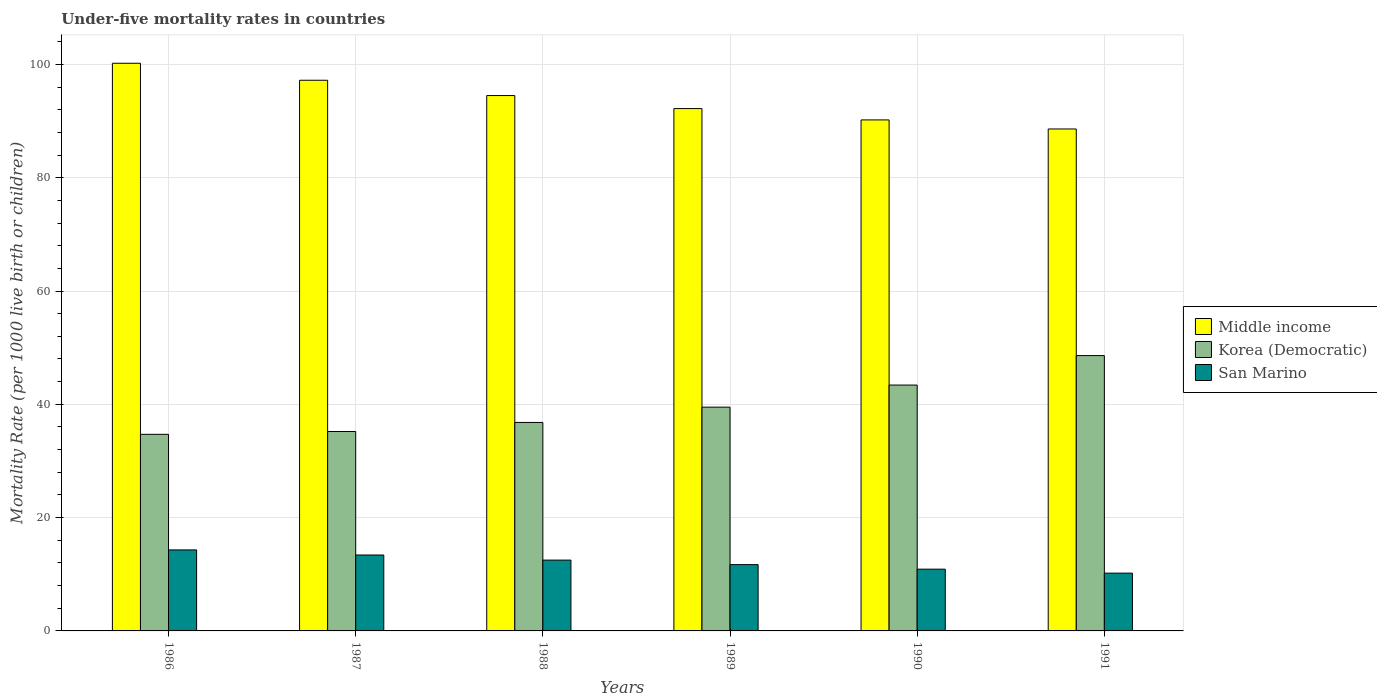How many groups of bars are there?
Provide a succinct answer. 6. What is the label of the 4th group of bars from the left?
Keep it short and to the point. 1989. What is the under-five mortality rate in Middle income in 1991?
Provide a short and direct response. 88.6. Across all years, what is the maximum under-five mortality rate in San Marino?
Offer a terse response. 14.3. Across all years, what is the minimum under-five mortality rate in Middle income?
Provide a short and direct response. 88.6. In which year was the under-five mortality rate in Korea (Democratic) maximum?
Provide a succinct answer. 1991. In which year was the under-five mortality rate in San Marino minimum?
Your response must be concise. 1991. What is the total under-five mortality rate in Middle income in the graph?
Give a very brief answer. 562.9. What is the difference between the under-five mortality rate in San Marino in 1986 and that in 1987?
Offer a terse response. 0.9. What is the difference between the under-five mortality rate in San Marino in 1987 and the under-five mortality rate in Middle income in 1989?
Keep it short and to the point. -78.8. What is the average under-five mortality rate in Korea (Democratic) per year?
Offer a very short reply. 39.7. In the year 1986, what is the difference between the under-five mortality rate in Korea (Democratic) and under-five mortality rate in San Marino?
Give a very brief answer. 20.4. In how many years, is the under-five mortality rate in Middle income greater than 96?
Offer a very short reply. 2. What is the ratio of the under-five mortality rate in Middle income in 1988 to that in 1990?
Provide a succinct answer. 1.05. Is the under-five mortality rate in Middle income in 1988 less than that in 1989?
Offer a very short reply. No. What is the difference between the highest and the second highest under-five mortality rate in San Marino?
Your response must be concise. 0.9. What is the difference between the highest and the lowest under-five mortality rate in Middle income?
Ensure brevity in your answer.  11.6. Is the sum of the under-five mortality rate in Middle income in 1989 and 1991 greater than the maximum under-five mortality rate in San Marino across all years?
Offer a terse response. Yes. What does the 3rd bar from the left in 1990 represents?
Offer a terse response. San Marino. What does the 3rd bar from the right in 1986 represents?
Provide a succinct answer. Middle income. Does the graph contain any zero values?
Your answer should be compact. No. How many legend labels are there?
Your answer should be very brief. 3. How are the legend labels stacked?
Ensure brevity in your answer.  Vertical. What is the title of the graph?
Your answer should be compact. Under-five mortality rates in countries. What is the label or title of the X-axis?
Keep it short and to the point. Years. What is the label or title of the Y-axis?
Your answer should be compact. Mortality Rate (per 1000 live birth or children). What is the Mortality Rate (per 1000 live birth or children) in Middle income in 1986?
Offer a terse response. 100.2. What is the Mortality Rate (per 1000 live birth or children) of Korea (Democratic) in 1986?
Provide a short and direct response. 34.7. What is the Mortality Rate (per 1000 live birth or children) in Middle income in 1987?
Provide a succinct answer. 97.2. What is the Mortality Rate (per 1000 live birth or children) of Korea (Democratic) in 1987?
Your answer should be very brief. 35.2. What is the Mortality Rate (per 1000 live birth or children) in Middle income in 1988?
Provide a short and direct response. 94.5. What is the Mortality Rate (per 1000 live birth or children) of Korea (Democratic) in 1988?
Provide a succinct answer. 36.8. What is the Mortality Rate (per 1000 live birth or children) of San Marino in 1988?
Give a very brief answer. 12.5. What is the Mortality Rate (per 1000 live birth or children) of Middle income in 1989?
Provide a short and direct response. 92.2. What is the Mortality Rate (per 1000 live birth or children) of Korea (Democratic) in 1989?
Keep it short and to the point. 39.5. What is the Mortality Rate (per 1000 live birth or children) in San Marino in 1989?
Ensure brevity in your answer.  11.7. What is the Mortality Rate (per 1000 live birth or children) in Middle income in 1990?
Provide a short and direct response. 90.2. What is the Mortality Rate (per 1000 live birth or children) of Korea (Democratic) in 1990?
Ensure brevity in your answer.  43.4. What is the Mortality Rate (per 1000 live birth or children) in Middle income in 1991?
Keep it short and to the point. 88.6. What is the Mortality Rate (per 1000 live birth or children) in Korea (Democratic) in 1991?
Your answer should be compact. 48.6. What is the Mortality Rate (per 1000 live birth or children) of San Marino in 1991?
Provide a short and direct response. 10.2. Across all years, what is the maximum Mortality Rate (per 1000 live birth or children) in Middle income?
Offer a terse response. 100.2. Across all years, what is the maximum Mortality Rate (per 1000 live birth or children) of Korea (Democratic)?
Your response must be concise. 48.6. Across all years, what is the maximum Mortality Rate (per 1000 live birth or children) in San Marino?
Your answer should be very brief. 14.3. Across all years, what is the minimum Mortality Rate (per 1000 live birth or children) of Middle income?
Keep it short and to the point. 88.6. Across all years, what is the minimum Mortality Rate (per 1000 live birth or children) of Korea (Democratic)?
Make the answer very short. 34.7. Across all years, what is the minimum Mortality Rate (per 1000 live birth or children) in San Marino?
Provide a succinct answer. 10.2. What is the total Mortality Rate (per 1000 live birth or children) of Middle income in the graph?
Give a very brief answer. 562.9. What is the total Mortality Rate (per 1000 live birth or children) of Korea (Democratic) in the graph?
Offer a very short reply. 238.2. What is the total Mortality Rate (per 1000 live birth or children) of San Marino in the graph?
Offer a terse response. 73. What is the difference between the Mortality Rate (per 1000 live birth or children) in Middle income in 1986 and that in 1987?
Your response must be concise. 3. What is the difference between the Mortality Rate (per 1000 live birth or children) of Korea (Democratic) in 1986 and that in 1987?
Provide a short and direct response. -0.5. What is the difference between the Mortality Rate (per 1000 live birth or children) in San Marino in 1986 and that in 1987?
Your response must be concise. 0.9. What is the difference between the Mortality Rate (per 1000 live birth or children) in Middle income in 1986 and that in 1988?
Make the answer very short. 5.7. What is the difference between the Mortality Rate (per 1000 live birth or children) of Korea (Democratic) in 1986 and that in 1988?
Provide a succinct answer. -2.1. What is the difference between the Mortality Rate (per 1000 live birth or children) of Middle income in 1986 and that in 1989?
Your answer should be compact. 8. What is the difference between the Mortality Rate (per 1000 live birth or children) in Korea (Democratic) in 1986 and that in 1989?
Provide a short and direct response. -4.8. What is the difference between the Mortality Rate (per 1000 live birth or children) of Korea (Democratic) in 1986 and that in 1990?
Give a very brief answer. -8.7. What is the difference between the Mortality Rate (per 1000 live birth or children) in San Marino in 1986 and that in 1990?
Your answer should be compact. 3.4. What is the difference between the Mortality Rate (per 1000 live birth or children) in Middle income in 1986 and that in 1991?
Your answer should be compact. 11.6. What is the difference between the Mortality Rate (per 1000 live birth or children) of Korea (Democratic) in 1986 and that in 1991?
Provide a short and direct response. -13.9. What is the difference between the Mortality Rate (per 1000 live birth or children) in Middle income in 1987 and that in 1988?
Offer a very short reply. 2.7. What is the difference between the Mortality Rate (per 1000 live birth or children) of Korea (Democratic) in 1987 and that in 1988?
Your response must be concise. -1.6. What is the difference between the Mortality Rate (per 1000 live birth or children) of Korea (Democratic) in 1987 and that in 1989?
Ensure brevity in your answer.  -4.3. What is the difference between the Mortality Rate (per 1000 live birth or children) in San Marino in 1987 and that in 1989?
Your answer should be very brief. 1.7. What is the difference between the Mortality Rate (per 1000 live birth or children) of Middle income in 1987 and that in 1990?
Your answer should be very brief. 7. What is the difference between the Mortality Rate (per 1000 live birth or children) in Korea (Democratic) in 1987 and that in 1990?
Ensure brevity in your answer.  -8.2. What is the difference between the Mortality Rate (per 1000 live birth or children) of Korea (Democratic) in 1987 and that in 1991?
Offer a very short reply. -13.4. What is the difference between the Mortality Rate (per 1000 live birth or children) of Middle income in 1988 and that in 1989?
Give a very brief answer. 2.3. What is the difference between the Mortality Rate (per 1000 live birth or children) in Middle income in 1988 and that in 1990?
Your answer should be very brief. 4.3. What is the difference between the Mortality Rate (per 1000 live birth or children) in Korea (Democratic) in 1988 and that in 1990?
Ensure brevity in your answer.  -6.6. What is the difference between the Mortality Rate (per 1000 live birth or children) of San Marino in 1988 and that in 1990?
Ensure brevity in your answer.  1.6. What is the difference between the Mortality Rate (per 1000 live birth or children) of Korea (Democratic) in 1988 and that in 1991?
Offer a terse response. -11.8. What is the difference between the Mortality Rate (per 1000 live birth or children) of Middle income in 1989 and that in 1990?
Your response must be concise. 2. What is the difference between the Mortality Rate (per 1000 live birth or children) in Korea (Democratic) in 1989 and that in 1990?
Ensure brevity in your answer.  -3.9. What is the difference between the Mortality Rate (per 1000 live birth or children) of Middle income in 1989 and that in 1991?
Make the answer very short. 3.6. What is the difference between the Mortality Rate (per 1000 live birth or children) of Korea (Democratic) in 1989 and that in 1991?
Your response must be concise. -9.1. What is the difference between the Mortality Rate (per 1000 live birth or children) in San Marino in 1989 and that in 1991?
Provide a short and direct response. 1.5. What is the difference between the Mortality Rate (per 1000 live birth or children) of Korea (Democratic) in 1990 and that in 1991?
Your answer should be very brief. -5.2. What is the difference between the Mortality Rate (per 1000 live birth or children) in Middle income in 1986 and the Mortality Rate (per 1000 live birth or children) in Korea (Democratic) in 1987?
Provide a succinct answer. 65. What is the difference between the Mortality Rate (per 1000 live birth or children) in Middle income in 1986 and the Mortality Rate (per 1000 live birth or children) in San Marino in 1987?
Give a very brief answer. 86.8. What is the difference between the Mortality Rate (per 1000 live birth or children) in Korea (Democratic) in 1986 and the Mortality Rate (per 1000 live birth or children) in San Marino in 1987?
Provide a succinct answer. 21.3. What is the difference between the Mortality Rate (per 1000 live birth or children) in Middle income in 1986 and the Mortality Rate (per 1000 live birth or children) in Korea (Democratic) in 1988?
Keep it short and to the point. 63.4. What is the difference between the Mortality Rate (per 1000 live birth or children) of Middle income in 1986 and the Mortality Rate (per 1000 live birth or children) of San Marino in 1988?
Your response must be concise. 87.7. What is the difference between the Mortality Rate (per 1000 live birth or children) in Middle income in 1986 and the Mortality Rate (per 1000 live birth or children) in Korea (Democratic) in 1989?
Provide a succinct answer. 60.7. What is the difference between the Mortality Rate (per 1000 live birth or children) of Middle income in 1986 and the Mortality Rate (per 1000 live birth or children) of San Marino in 1989?
Your answer should be compact. 88.5. What is the difference between the Mortality Rate (per 1000 live birth or children) of Korea (Democratic) in 1986 and the Mortality Rate (per 1000 live birth or children) of San Marino in 1989?
Your answer should be very brief. 23. What is the difference between the Mortality Rate (per 1000 live birth or children) in Middle income in 1986 and the Mortality Rate (per 1000 live birth or children) in Korea (Democratic) in 1990?
Offer a terse response. 56.8. What is the difference between the Mortality Rate (per 1000 live birth or children) of Middle income in 1986 and the Mortality Rate (per 1000 live birth or children) of San Marino in 1990?
Give a very brief answer. 89.3. What is the difference between the Mortality Rate (per 1000 live birth or children) in Korea (Democratic) in 1986 and the Mortality Rate (per 1000 live birth or children) in San Marino in 1990?
Your response must be concise. 23.8. What is the difference between the Mortality Rate (per 1000 live birth or children) of Middle income in 1986 and the Mortality Rate (per 1000 live birth or children) of Korea (Democratic) in 1991?
Ensure brevity in your answer.  51.6. What is the difference between the Mortality Rate (per 1000 live birth or children) of Middle income in 1987 and the Mortality Rate (per 1000 live birth or children) of Korea (Democratic) in 1988?
Your answer should be very brief. 60.4. What is the difference between the Mortality Rate (per 1000 live birth or children) of Middle income in 1987 and the Mortality Rate (per 1000 live birth or children) of San Marino in 1988?
Ensure brevity in your answer.  84.7. What is the difference between the Mortality Rate (per 1000 live birth or children) in Korea (Democratic) in 1987 and the Mortality Rate (per 1000 live birth or children) in San Marino in 1988?
Your answer should be very brief. 22.7. What is the difference between the Mortality Rate (per 1000 live birth or children) in Middle income in 1987 and the Mortality Rate (per 1000 live birth or children) in Korea (Democratic) in 1989?
Offer a very short reply. 57.7. What is the difference between the Mortality Rate (per 1000 live birth or children) of Middle income in 1987 and the Mortality Rate (per 1000 live birth or children) of San Marino in 1989?
Your answer should be compact. 85.5. What is the difference between the Mortality Rate (per 1000 live birth or children) of Middle income in 1987 and the Mortality Rate (per 1000 live birth or children) of Korea (Democratic) in 1990?
Ensure brevity in your answer.  53.8. What is the difference between the Mortality Rate (per 1000 live birth or children) in Middle income in 1987 and the Mortality Rate (per 1000 live birth or children) in San Marino in 1990?
Offer a terse response. 86.3. What is the difference between the Mortality Rate (per 1000 live birth or children) of Korea (Democratic) in 1987 and the Mortality Rate (per 1000 live birth or children) of San Marino in 1990?
Provide a short and direct response. 24.3. What is the difference between the Mortality Rate (per 1000 live birth or children) in Middle income in 1987 and the Mortality Rate (per 1000 live birth or children) in Korea (Democratic) in 1991?
Your response must be concise. 48.6. What is the difference between the Mortality Rate (per 1000 live birth or children) in Middle income in 1987 and the Mortality Rate (per 1000 live birth or children) in San Marino in 1991?
Ensure brevity in your answer.  87. What is the difference between the Mortality Rate (per 1000 live birth or children) of Korea (Democratic) in 1987 and the Mortality Rate (per 1000 live birth or children) of San Marino in 1991?
Provide a short and direct response. 25. What is the difference between the Mortality Rate (per 1000 live birth or children) in Middle income in 1988 and the Mortality Rate (per 1000 live birth or children) in San Marino in 1989?
Offer a very short reply. 82.8. What is the difference between the Mortality Rate (per 1000 live birth or children) of Korea (Democratic) in 1988 and the Mortality Rate (per 1000 live birth or children) of San Marino in 1989?
Your answer should be compact. 25.1. What is the difference between the Mortality Rate (per 1000 live birth or children) of Middle income in 1988 and the Mortality Rate (per 1000 live birth or children) of Korea (Democratic) in 1990?
Keep it short and to the point. 51.1. What is the difference between the Mortality Rate (per 1000 live birth or children) in Middle income in 1988 and the Mortality Rate (per 1000 live birth or children) in San Marino in 1990?
Keep it short and to the point. 83.6. What is the difference between the Mortality Rate (per 1000 live birth or children) in Korea (Democratic) in 1988 and the Mortality Rate (per 1000 live birth or children) in San Marino in 1990?
Provide a short and direct response. 25.9. What is the difference between the Mortality Rate (per 1000 live birth or children) in Middle income in 1988 and the Mortality Rate (per 1000 live birth or children) in Korea (Democratic) in 1991?
Offer a terse response. 45.9. What is the difference between the Mortality Rate (per 1000 live birth or children) in Middle income in 1988 and the Mortality Rate (per 1000 live birth or children) in San Marino in 1991?
Offer a terse response. 84.3. What is the difference between the Mortality Rate (per 1000 live birth or children) in Korea (Democratic) in 1988 and the Mortality Rate (per 1000 live birth or children) in San Marino in 1991?
Make the answer very short. 26.6. What is the difference between the Mortality Rate (per 1000 live birth or children) of Middle income in 1989 and the Mortality Rate (per 1000 live birth or children) of Korea (Democratic) in 1990?
Your response must be concise. 48.8. What is the difference between the Mortality Rate (per 1000 live birth or children) in Middle income in 1989 and the Mortality Rate (per 1000 live birth or children) in San Marino in 1990?
Your response must be concise. 81.3. What is the difference between the Mortality Rate (per 1000 live birth or children) in Korea (Democratic) in 1989 and the Mortality Rate (per 1000 live birth or children) in San Marino in 1990?
Your answer should be very brief. 28.6. What is the difference between the Mortality Rate (per 1000 live birth or children) of Middle income in 1989 and the Mortality Rate (per 1000 live birth or children) of Korea (Democratic) in 1991?
Provide a succinct answer. 43.6. What is the difference between the Mortality Rate (per 1000 live birth or children) of Korea (Democratic) in 1989 and the Mortality Rate (per 1000 live birth or children) of San Marino in 1991?
Your answer should be compact. 29.3. What is the difference between the Mortality Rate (per 1000 live birth or children) in Middle income in 1990 and the Mortality Rate (per 1000 live birth or children) in Korea (Democratic) in 1991?
Provide a succinct answer. 41.6. What is the difference between the Mortality Rate (per 1000 live birth or children) in Korea (Democratic) in 1990 and the Mortality Rate (per 1000 live birth or children) in San Marino in 1991?
Offer a terse response. 33.2. What is the average Mortality Rate (per 1000 live birth or children) of Middle income per year?
Your answer should be very brief. 93.82. What is the average Mortality Rate (per 1000 live birth or children) of Korea (Democratic) per year?
Provide a short and direct response. 39.7. What is the average Mortality Rate (per 1000 live birth or children) of San Marino per year?
Keep it short and to the point. 12.17. In the year 1986, what is the difference between the Mortality Rate (per 1000 live birth or children) of Middle income and Mortality Rate (per 1000 live birth or children) of Korea (Democratic)?
Make the answer very short. 65.5. In the year 1986, what is the difference between the Mortality Rate (per 1000 live birth or children) in Middle income and Mortality Rate (per 1000 live birth or children) in San Marino?
Make the answer very short. 85.9. In the year 1986, what is the difference between the Mortality Rate (per 1000 live birth or children) of Korea (Democratic) and Mortality Rate (per 1000 live birth or children) of San Marino?
Offer a very short reply. 20.4. In the year 1987, what is the difference between the Mortality Rate (per 1000 live birth or children) in Middle income and Mortality Rate (per 1000 live birth or children) in San Marino?
Provide a succinct answer. 83.8. In the year 1987, what is the difference between the Mortality Rate (per 1000 live birth or children) in Korea (Democratic) and Mortality Rate (per 1000 live birth or children) in San Marino?
Offer a terse response. 21.8. In the year 1988, what is the difference between the Mortality Rate (per 1000 live birth or children) of Middle income and Mortality Rate (per 1000 live birth or children) of Korea (Democratic)?
Provide a short and direct response. 57.7. In the year 1988, what is the difference between the Mortality Rate (per 1000 live birth or children) in Middle income and Mortality Rate (per 1000 live birth or children) in San Marino?
Provide a short and direct response. 82. In the year 1988, what is the difference between the Mortality Rate (per 1000 live birth or children) of Korea (Democratic) and Mortality Rate (per 1000 live birth or children) of San Marino?
Your answer should be compact. 24.3. In the year 1989, what is the difference between the Mortality Rate (per 1000 live birth or children) of Middle income and Mortality Rate (per 1000 live birth or children) of Korea (Democratic)?
Provide a short and direct response. 52.7. In the year 1989, what is the difference between the Mortality Rate (per 1000 live birth or children) of Middle income and Mortality Rate (per 1000 live birth or children) of San Marino?
Make the answer very short. 80.5. In the year 1989, what is the difference between the Mortality Rate (per 1000 live birth or children) in Korea (Democratic) and Mortality Rate (per 1000 live birth or children) in San Marino?
Provide a short and direct response. 27.8. In the year 1990, what is the difference between the Mortality Rate (per 1000 live birth or children) in Middle income and Mortality Rate (per 1000 live birth or children) in Korea (Democratic)?
Make the answer very short. 46.8. In the year 1990, what is the difference between the Mortality Rate (per 1000 live birth or children) in Middle income and Mortality Rate (per 1000 live birth or children) in San Marino?
Offer a very short reply. 79.3. In the year 1990, what is the difference between the Mortality Rate (per 1000 live birth or children) in Korea (Democratic) and Mortality Rate (per 1000 live birth or children) in San Marino?
Offer a very short reply. 32.5. In the year 1991, what is the difference between the Mortality Rate (per 1000 live birth or children) in Middle income and Mortality Rate (per 1000 live birth or children) in Korea (Democratic)?
Offer a very short reply. 40. In the year 1991, what is the difference between the Mortality Rate (per 1000 live birth or children) in Middle income and Mortality Rate (per 1000 live birth or children) in San Marino?
Your answer should be compact. 78.4. In the year 1991, what is the difference between the Mortality Rate (per 1000 live birth or children) in Korea (Democratic) and Mortality Rate (per 1000 live birth or children) in San Marino?
Provide a succinct answer. 38.4. What is the ratio of the Mortality Rate (per 1000 live birth or children) in Middle income in 1986 to that in 1987?
Give a very brief answer. 1.03. What is the ratio of the Mortality Rate (per 1000 live birth or children) of Korea (Democratic) in 1986 to that in 1987?
Keep it short and to the point. 0.99. What is the ratio of the Mortality Rate (per 1000 live birth or children) in San Marino in 1986 to that in 1987?
Keep it short and to the point. 1.07. What is the ratio of the Mortality Rate (per 1000 live birth or children) of Middle income in 1986 to that in 1988?
Your response must be concise. 1.06. What is the ratio of the Mortality Rate (per 1000 live birth or children) in Korea (Democratic) in 1986 to that in 1988?
Give a very brief answer. 0.94. What is the ratio of the Mortality Rate (per 1000 live birth or children) in San Marino in 1986 to that in 1988?
Provide a succinct answer. 1.14. What is the ratio of the Mortality Rate (per 1000 live birth or children) of Middle income in 1986 to that in 1989?
Ensure brevity in your answer.  1.09. What is the ratio of the Mortality Rate (per 1000 live birth or children) of Korea (Democratic) in 1986 to that in 1989?
Your response must be concise. 0.88. What is the ratio of the Mortality Rate (per 1000 live birth or children) in San Marino in 1986 to that in 1989?
Keep it short and to the point. 1.22. What is the ratio of the Mortality Rate (per 1000 live birth or children) in Middle income in 1986 to that in 1990?
Offer a very short reply. 1.11. What is the ratio of the Mortality Rate (per 1000 live birth or children) of Korea (Democratic) in 1986 to that in 1990?
Ensure brevity in your answer.  0.8. What is the ratio of the Mortality Rate (per 1000 live birth or children) of San Marino in 1986 to that in 1990?
Provide a succinct answer. 1.31. What is the ratio of the Mortality Rate (per 1000 live birth or children) of Middle income in 1986 to that in 1991?
Your answer should be very brief. 1.13. What is the ratio of the Mortality Rate (per 1000 live birth or children) of Korea (Democratic) in 1986 to that in 1991?
Ensure brevity in your answer.  0.71. What is the ratio of the Mortality Rate (per 1000 live birth or children) of San Marino in 1986 to that in 1991?
Provide a short and direct response. 1.4. What is the ratio of the Mortality Rate (per 1000 live birth or children) of Middle income in 1987 to that in 1988?
Provide a short and direct response. 1.03. What is the ratio of the Mortality Rate (per 1000 live birth or children) in Korea (Democratic) in 1987 to that in 1988?
Your answer should be very brief. 0.96. What is the ratio of the Mortality Rate (per 1000 live birth or children) in San Marino in 1987 to that in 1988?
Offer a very short reply. 1.07. What is the ratio of the Mortality Rate (per 1000 live birth or children) of Middle income in 1987 to that in 1989?
Your answer should be compact. 1.05. What is the ratio of the Mortality Rate (per 1000 live birth or children) of Korea (Democratic) in 1987 to that in 1989?
Your response must be concise. 0.89. What is the ratio of the Mortality Rate (per 1000 live birth or children) of San Marino in 1987 to that in 1989?
Your answer should be compact. 1.15. What is the ratio of the Mortality Rate (per 1000 live birth or children) of Middle income in 1987 to that in 1990?
Your answer should be very brief. 1.08. What is the ratio of the Mortality Rate (per 1000 live birth or children) of Korea (Democratic) in 1987 to that in 1990?
Provide a succinct answer. 0.81. What is the ratio of the Mortality Rate (per 1000 live birth or children) of San Marino in 1987 to that in 1990?
Ensure brevity in your answer.  1.23. What is the ratio of the Mortality Rate (per 1000 live birth or children) in Middle income in 1987 to that in 1991?
Make the answer very short. 1.1. What is the ratio of the Mortality Rate (per 1000 live birth or children) in Korea (Democratic) in 1987 to that in 1991?
Offer a very short reply. 0.72. What is the ratio of the Mortality Rate (per 1000 live birth or children) of San Marino in 1987 to that in 1991?
Offer a terse response. 1.31. What is the ratio of the Mortality Rate (per 1000 live birth or children) in Middle income in 1988 to that in 1989?
Ensure brevity in your answer.  1.02. What is the ratio of the Mortality Rate (per 1000 live birth or children) of Korea (Democratic) in 1988 to that in 1989?
Give a very brief answer. 0.93. What is the ratio of the Mortality Rate (per 1000 live birth or children) of San Marino in 1988 to that in 1989?
Ensure brevity in your answer.  1.07. What is the ratio of the Mortality Rate (per 1000 live birth or children) in Middle income in 1988 to that in 1990?
Ensure brevity in your answer.  1.05. What is the ratio of the Mortality Rate (per 1000 live birth or children) of Korea (Democratic) in 1988 to that in 1990?
Your response must be concise. 0.85. What is the ratio of the Mortality Rate (per 1000 live birth or children) in San Marino in 1988 to that in 1990?
Give a very brief answer. 1.15. What is the ratio of the Mortality Rate (per 1000 live birth or children) in Middle income in 1988 to that in 1991?
Give a very brief answer. 1.07. What is the ratio of the Mortality Rate (per 1000 live birth or children) in Korea (Democratic) in 1988 to that in 1991?
Offer a terse response. 0.76. What is the ratio of the Mortality Rate (per 1000 live birth or children) in San Marino in 1988 to that in 1991?
Keep it short and to the point. 1.23. What is the ratio of the Mortality Rate (per 1000 live birth or children) in Middle income in 1989 to that in 1990?
Offer a very short reply. 1.02. What is the ratio of the Mortality Rate (per 1000 live birth or children) of Korea (Democratic) in 1989 to that in 1990?
Your response must be concise. 0.91. What is the ratio of the Mortality Rate (per 1000 live birth or children) in San Marino in 1989 to that in 1990?
Your response must be concise. 1.07. What is the ratio of the Mortality Rate (per 1000 live birth or children) of Middle income in 1989 to that in 1991?
Keep it short and to the point. 1.04. What is the ratio of the Mortality Rate (per 1000 live birth or children) of Korea (Democratic) in 1989 to that in 1991?
Your answer should be compact. 0.81. What is the ratio of the Mortality Rate (per 1000 live birth or children) of San Marino in 1989 to that in 1991?
Offer a very short reply. 1.15. What is the ratio of the Mortality Rate (per 1000 live birth or children) of Middle income in 1990 to that in 1991?
Provide a short and direct response. 1.02. What is the ratio of the Mortality Rate (per 1000 live birth or children) in Korea (Democratic) in 1990 to that in 1991?
Offer a terse response. 0.89. What is the ratio of the Mortality Rate (per 1000 live birth or children) of San Marino in 1990 to that in 1991?
Make the answer very short. 1.07. What is the difference between the highest and the lowest Mortality Rate (per 1000 live birth or children) of Korea (Democratic)?
Give a very brief answer. 13.9. 